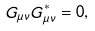Convert formula to latex. <formula><loc_0><loc_0><loc_500><loc_500>G _ { \mu \nu } G _ { \mu \nu } ^ { * } = 0 ,</formula> 